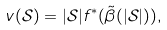Convert formula to latex. <formula><loc_0><loc_0><loc_500><loc_500>v ( \mathcal { S } ) = | \mathcal { S } | f ^ { * } ( \tilde { \beta } ( | \mathcal { S } | ) ) ,</formula> 